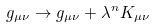<formula> <loc_0><loc_0><loc_500><loc_500>g _ { \mu \nu } \rightarrow g _ { \mu \nu } + { \lambda } ^ { n } K _ { \mu \nu }</formula> 